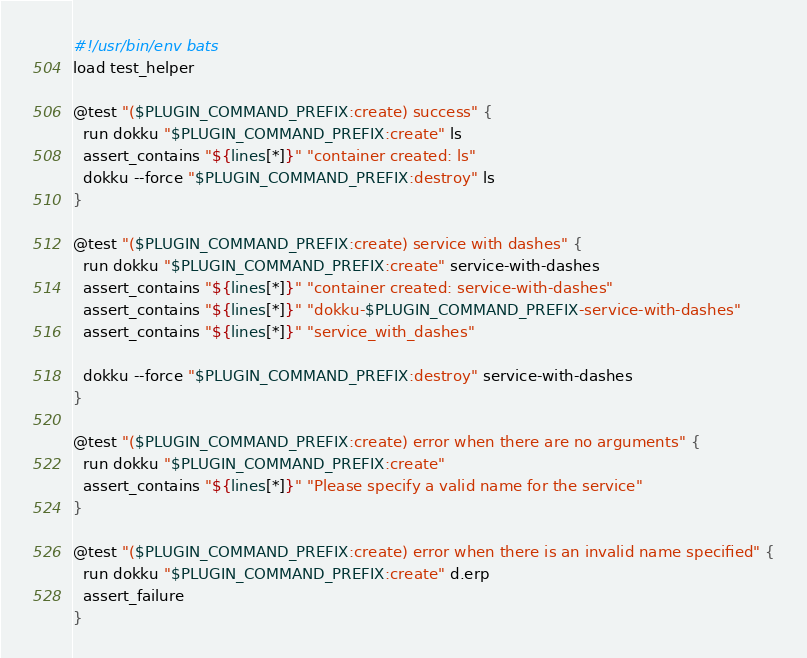Convert code to text. <code><loc_0><loc_0><loc_500><loc_500><_Bash_>#!/usr/bin/env bats
load test_helper

@test "($PLUGIN_COMMAND_PREFIX:create) success" {
  run dokku "$PLUGIN_COMMAND_PREFIX:create" ls
  assert_contains "${lines[*]}" "container created: ls"
  dokku --force "$PLUGIN_COMMAND_PREFIX:destroy" ls
}

@test "($PLUGIN_COMMAND_PREFIX:create) service with dashes" {
  run dokku "$PLUGIN_COMMAND_PREFIX:create" service-with-dashes
  assert_contains "${lines[*]}" "container created: service-with-dashes"
  assert_contains "${lines[*]}" "dokku-$PLUGIN_COMMAND_PREFIX-service-with-dashes"
  assert_contains "${lines[*]}" "service_with_dashes"

  dokku --force "$PLUGIN_COMMAND_PREFIX:destroy" service-with-dashes
}

@test "($PLUGIN_COMMAND_PREFIX:create) error when there are no arguments" {
  run dokku "$PLUGIN_COMMAND_PREFIX:create"
  assert_contains "${lines[*]}" "Please specify a valid name for the service"
}

@test "($PLUGIN_COMMAND_PREFIX:create) error when there is an invalid name specified" {
  run dokku "$PLUGIN_COMMAND_PREFIX:create" d.erp
  assert_failure
}
</code> 